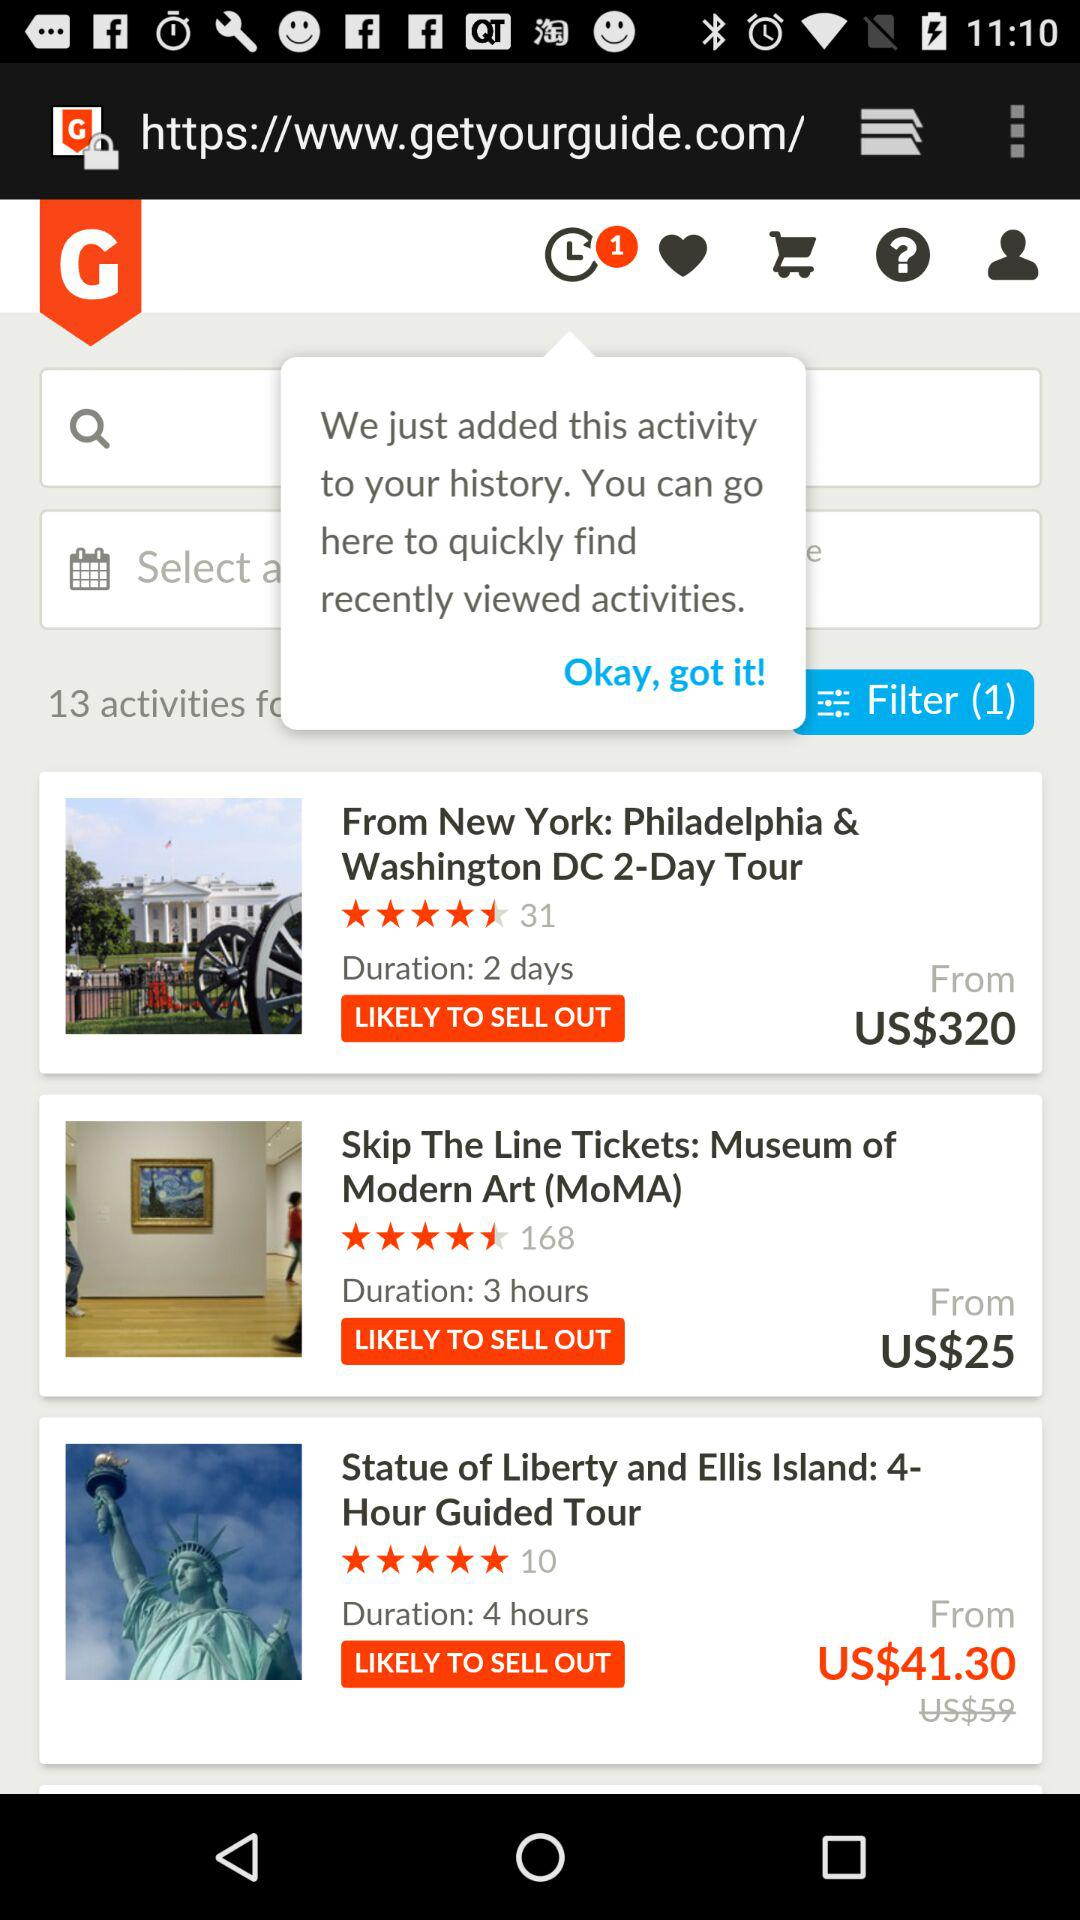What duration is mentioned for "Statue of Liberty and Ellis Island"? The duration that is mentioned for "Statue of Liberty and Ellis Island" is 4 hours. 